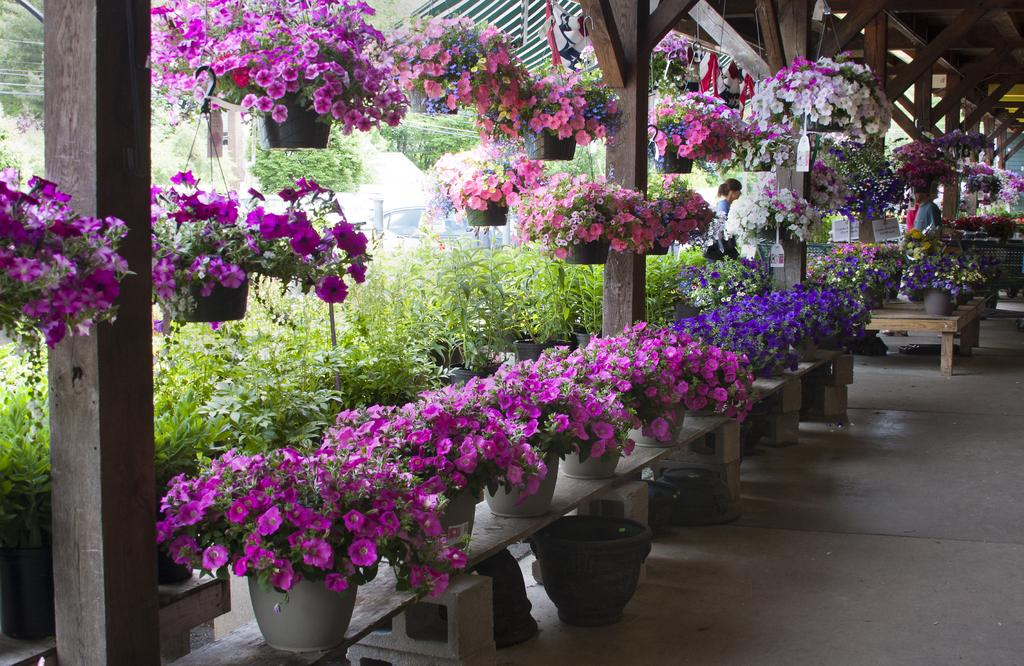What type of location is depicted in the image? The image is of a nursery. What can be seen in the nursery besides the plants? There are flower pots of different colors in the image. Where are the flower pots located? The flower pots are on benches. How many people are in the image? There are two persons in the image. What type of bird can be seen taking a bath in the image? There is no bird or bath present in the image; it is a nursery with flower pots on benches and two people. 